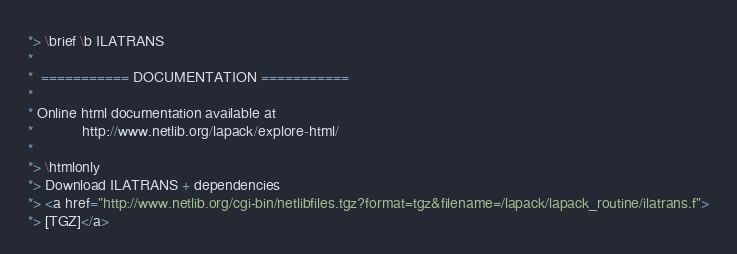Convert code to text. <code><loc_0><loc_0><loc_500><loc_500><_FORTRAN_>*> \brief \b ILATRANS
*
*  =========== DOCUMENTATION ===========
*
* Online html documentation available at
*            http://www.netlib.org/lapack/explore-html/
*
*> \htmlonly
*> Download ILATRANS + dependencies
*> <a href="http://www.netlib.org/cgi-bin/netlibfiles.tgz?format=tgz&filename=/lapack/lapack_routine/ilatrans.f">
*> [TGZ]</a></code> 